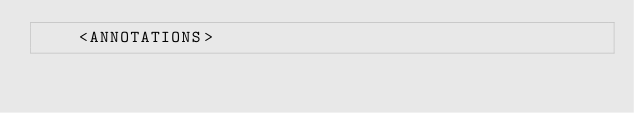Convert code to text. <code><loc_0><loc_0><loc_500><loc_500><_XML_>    <ANNOTATIONS></code> 